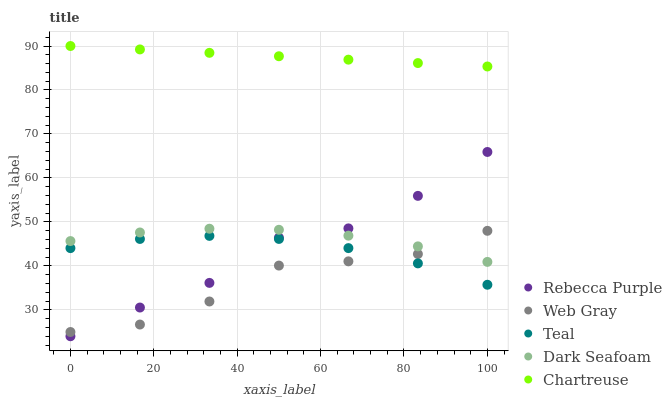Does Web Gray have the minimum area under the curve?
Answer yes or no. Yes. Does Chartreuse have the maximum area under the curve?
Answer yes or no. Yes. Does Dark Seafoam have the minimum area under the curve?
Answer yes or no. No. Does Dark Seafoam have the maximum area under the curve?
Answer yes or no. No. Is Chartreuse the smoothest?
Answer yes or no. Yes. Is Rebecca Purple the roughest?
Answer yes or no. Yes. Is Dark Seafoam the smoothest?
Answer yes or no. No. Is Dark Seafoam the roughest?
Answer yes or no. No. Does Rebecca Purple have the lowest value?
Answer yes or no. Yes. Does Dark Seafoam have the lowest value?
Answer yes or no. No. Does Chartreuse have the highest value?
Answer yes or no. Yes. Does Dark Seafoam have the highest value?
Answer yes or no. No. Is Rebecca Purple less than Chartreuse?
Answer yes or no. Yes. Is Chartreuse greater than Teal?
Answer yes or no. Yes. Does Web Gray intersect Dark Seafoam?
Answer yes or no. Yes. Is Web Gray less than Dark Seafoam?
Answer yes or no. No. Is Web Gray greater than Dark Seafoam?
Answer yes or no. No. Does Rebecca Purple intersect Chartreuse?
Answer yes or no. No. 